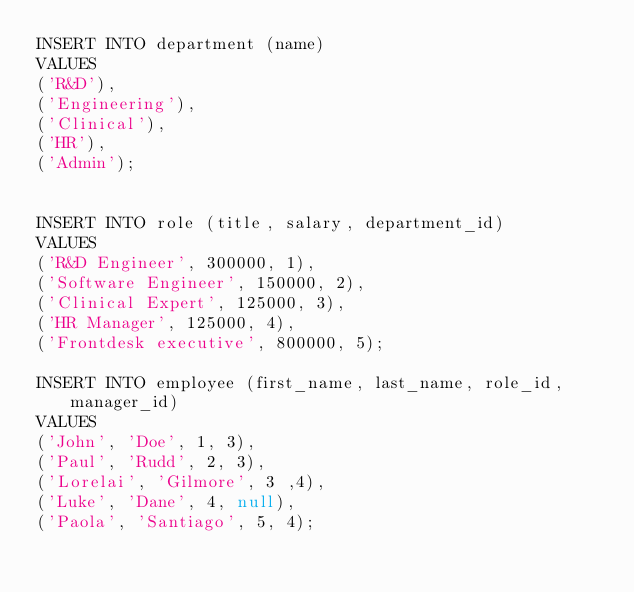Convert code to text. <code><loc_0><loc_0><loc_500><loc_500><_SQL_>INSERT INTO department (name)
VALUES 
('R&D'),
('Engineering'),
('Clinical'),
('HR'),
('Admin');


INSERT INTO role (title, salary, department_id)
VALUES 
('R&D Engineer', 300000, 1),  
('Software Engineer', 150000, 2), 
('Clinical Expert', 125000, 3), 
('HR Manager', 125000, 4), 
('Frontdesk executive', 800000, 5);

INSERT INTO employee (first_name, last_name, role_id, manager_id) 
VALUES 
('John', 'Doe', 1, 3), 
('Paul', 'Rudd', 2, 3), 
('Lorelai', 'Gilmore', 3 ,4), 
('Luke', 'Dane', 4, null), 
('Paola', 'Santiago', 5, 4);
</code> 